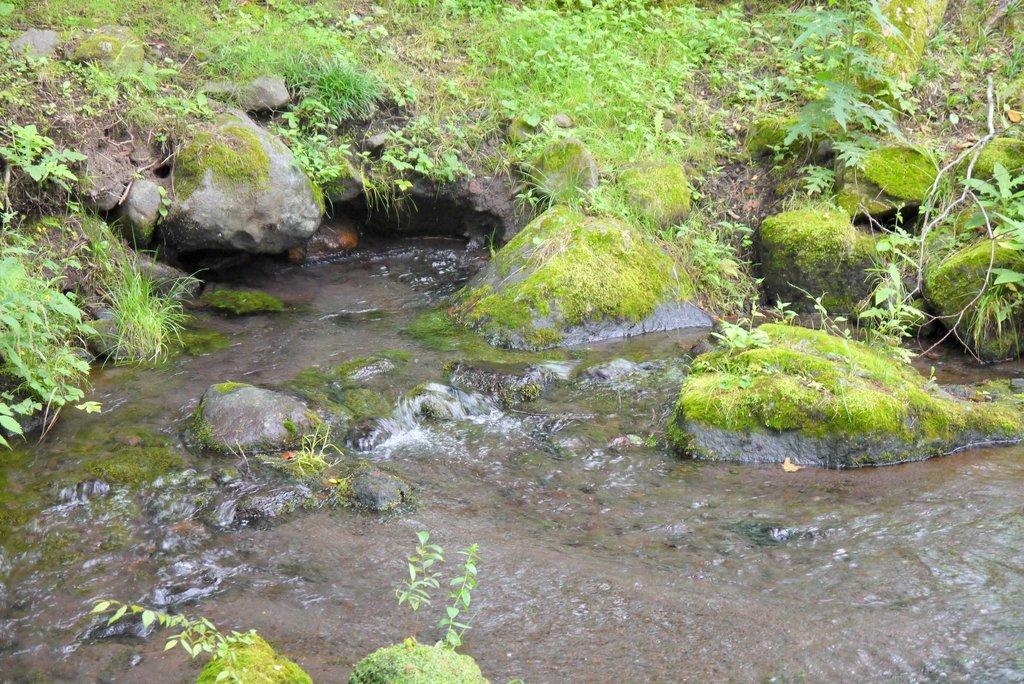Please provide a concise description of this image. In this image I can see the water and few rocks in it. I can also see the grass to the side of the water. 